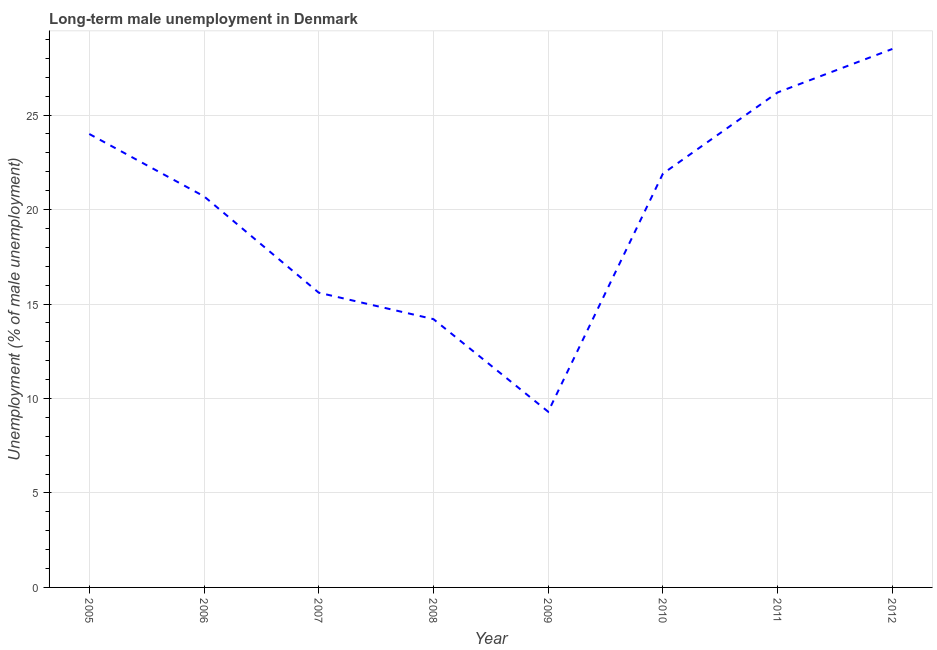What is the long-term male unemployment in 2011?
Give a very brief answer. 26.2. Across all years, what is the maximum long-term male unemployment?
Make the answer very short. 28.5. Across all years, what is the minimum long-term male unemployment?
Keep it short and to the point. 9.3. What is the sum of the long-term male unemployment?
Ensure brevity in your answer.  160.4. What is the difference between the long-term male unemployment in 2009 and 2010?
Keep it short and to the point. -12.6. What is the average long-term male unemployment per year?
Your response must be concise. 20.05. What is the median long-term male unemployment?
Give a very brief answer. 21.3. In how many years, is the long-term male unemployment greater than 7 %?
Keep it short and to the point. 8. Do a majority of the years between 2006 and 2005 (inclusive) have long-term male unemployment greater than 21 %?
Your response must be concise. No. What is the ratio of the long-term male unemployment in 2008 to that in 2011?
Provide a succinct answer. 0.54. Is the difference between the long-term male unemployment in 2009 and 2012 greater than the difference between any two years?
Offer a terse response. Yes. What is the difference between the highest and the second highest long-term male unemployment?
Offer a very short reply. 2.3. Is the sum of the long-term male unemployment in 2008 and 2012 greater than the maximum long-term male unemployment across all years?
Provide a succinct answer. Yes. What is the difference between the highest and the lowest long-term male unemployment?
Keep it short and to the point. 19.2. In how many years, is the long-term male unemployment greater than the average long-term male unemployment taken over all years?
Offer a very short reply. 5. Does the long-term male unemployment monotonically increase over the years?
Offer a very short reply. No. How many lines are there?
Offer a very short reply. 1. How many years are there in the graph?
Your answer should be compact. 8. Does the graph contain any zero values?
Ensure brevity in your answer.  No. What is the title of the graph?
Provide a succinct answer. Long-term male unemployment in Denmark. What is the label or title of the Y-axis?
Provide a short and direct response. Unemployment (% of male unemployment). What is the Unemployment (% of male unemployment) of 2005?
Offer a terse response. 24. What is the Unemployment (% of male unemployment) of 2006?
Your answer should be compact. 20.7. What is the Unemployment (% of male unemployment) in 2007?
Ensure brevity in your answer.  15.6. What is the Unemployment (% of male unemployment) in 2008?
Provide a succinct answer. 14.2. What is the Unemployment (% of male unemployment) of 2009?
Offer a terse response. 9.3. What is the Unemployment (% of male unemployment) of 2010?
Provide a succinct answer. 21.9. What is the Unemployment (% of male unemployment) in 2011?
Provide a succinct answer. 26.2. What is the Unemployment (% of male unemployment) in 2012?
Your response must be concise. 28.5. What is the difference between the Unemployment (% of male unemployment) in 2005 and 2007?
Your answer should be very brief. 8.4. What is the difference between the Unemployment (% of male unemployment) in 2005 and 2009?
Your answer should be compact. 14.7. What is the difference between the Unemployment (% of male unemployment) in 2005 and 2010?
Offer a very short reply. 2.1. What is the difference between the Unemployment (% of male unemployment) in 2005 and 2011?
Ensure brevity in your answer.  -2.2. What is the difference between the Unemployment (% of male unemployment) in 2006 and 2007?
Your answer should be compact. 5.1. What is the difference between the Unemployment (% of male unemployment) in 2006 and 2011?
Offer a very short reply. -5.5. What is the difference between the Unemployment (% of male unemployment) in 2007 and 2009?
Ensure brevity in your answer.  6.3. What is the difference between the Unemployment (% of male unemployment) in 2007 and 2010?
Provide a succinct answer. -6.3. What is the difference between the Unemployment (% of male unemployment) in 2007 and 2012?
Your answer should be very brief. -12.9. What is the difference between the Unemployment (% of male unemployment) in 2008 and 2012?
Provide a succinct answer. -14.3. What is the difference between the Unemployment (% of male unemployment) in 2009 and 2010?
Offer a very short reply. -12.6. What is the difference between the Unemployment (% of male unemployment) in 2009 and 2011?
Provide a short and direct response. -16.9. What is the difference between the Unemployment (% of male unemployment) in 2009 and 2012?
Make the answer very short. -19.2. What is the difference between the Unemployment (% of male unemployment) in 2010 and 2011?
Give a very brief answer. -4.3. What is the difference between the Unemployment (% of male unemployment) in 2011 and 2012?
Make the answer very short. -2.3. What is the ratio of the Unemployment (% of male unemployment) in 2005 to that in 2006?
Make the answer very short. 1.16. What is the ratio of the Unemployment (% of male unemployment) in 2005 to that in 2007?
Your response must be concise. 1.54. What is the ratio of the Unemployment (% of male unemployment) in 2005 to that in 2008?
Provide a short and direct response. 1.69. What is the ratio of the Unemployment (% of male unemployment) in 2005 to that in 2009?
Your answer should be compact. 2.58. What is the ratio of the Unemployment (% of male unemployment) in 2005 to that in 2010?
Your answer should be very brief. 1.1. What is the ratio of the Unemployment (% of male unemployment) in 2005 to that in 2011?
Provide a short and direct response. 0.92. What is the ratio of the Unemployment (% of male unemployment) in 2005 to that in 2012?
Give a very brief answer. 0.84. What is the ratio of the Unemployment (% of male unemployment) in 2006 to that in 2007?
Make the answer very short. 1.33. What is the ratio of the Unemployment (% of male unemployment) in 2006 to that in 2008?
Provide a short and direct response. 1.46. What is the ratio of the Unemployment (% of male unemployment) in 2006 to that in 2009?
Keep it short and to the point. 2.23. What is the ratio of the Unemployment (% of male unemployment) in 2006 to that in 2010?
Offer a very short reply. 0.94. What is the ratio of the Unemployment (% of male unemployment) in 2006 to that in 2011?
Keep it short and to the point. 0.79. What is the ratio of the Unemployment (% of male unemployment) in 2006 to that in 2012?
Provide a succinct answer. 0.73. What is the ratio of the Unemployment (% of male unemployment) in 2007 to that in 2008?
Make the answer very short. 1.1. What is the ratio of the Unemployment (% of male unemployment) in 2007 to that in 2009?
Your response must be concise. 1.68. What is the ratio of the Unemployment (% of male unemployment) in 2007 to that in 2010?
Keep it short and to the point. 0.71. What is the ratio of the Unemployment (% of male unemployment) in 2007 to that in 2011?
Your answer should be compact. 0.59. What is the ratio of the Unemployment (% of male unemployment) in 2007 to that in 2012?
Your response must be concise. 0.55. What is the ratio of the Unemployment (% of male unemployment) in 2008 to that in 2009?
Offer a very short reply. 1.53. What is the ratio of the Unemployment (% of male unemployment) in 2008 to that in 2010?
Provide a succinct answer. 0.65. What is the ratio of the Unemployment (% of male unemployment) in 2008 to that in 2011?
Offer a terse response. 0.54. What is the ratio of the Unemployment (% of male unemployment) in 2008 to that in 2012?
Offer a terse response. 0.5. What is the ratio of the Unemployment (% of male unemployment) in 2009 to that in 2010?
Offer a terse response. 0.42. What is the ratio of the Unemployment (% of male unemployment) in 2009 to that in 2011?
Ensure brevity in your answer.  0.35. What is the ratio of the Unemployment (% of male unemployment) in 2009 to that in 2012?
Give a very brief answer. 0.33. What is the ratio of the Unemployment (% of male unemployment) in 2010 to that in 2011?
Offer a very short reply. 0.84. What is the ratio of the Unemployment (% of male unemployment) in 2010 to that in 2012?
Your response must be concise. 0.77. What is the ratio of the Unemployment (% of male unemployment) in 2011 to that in 2012?
Your response must be concise. 0.92. 